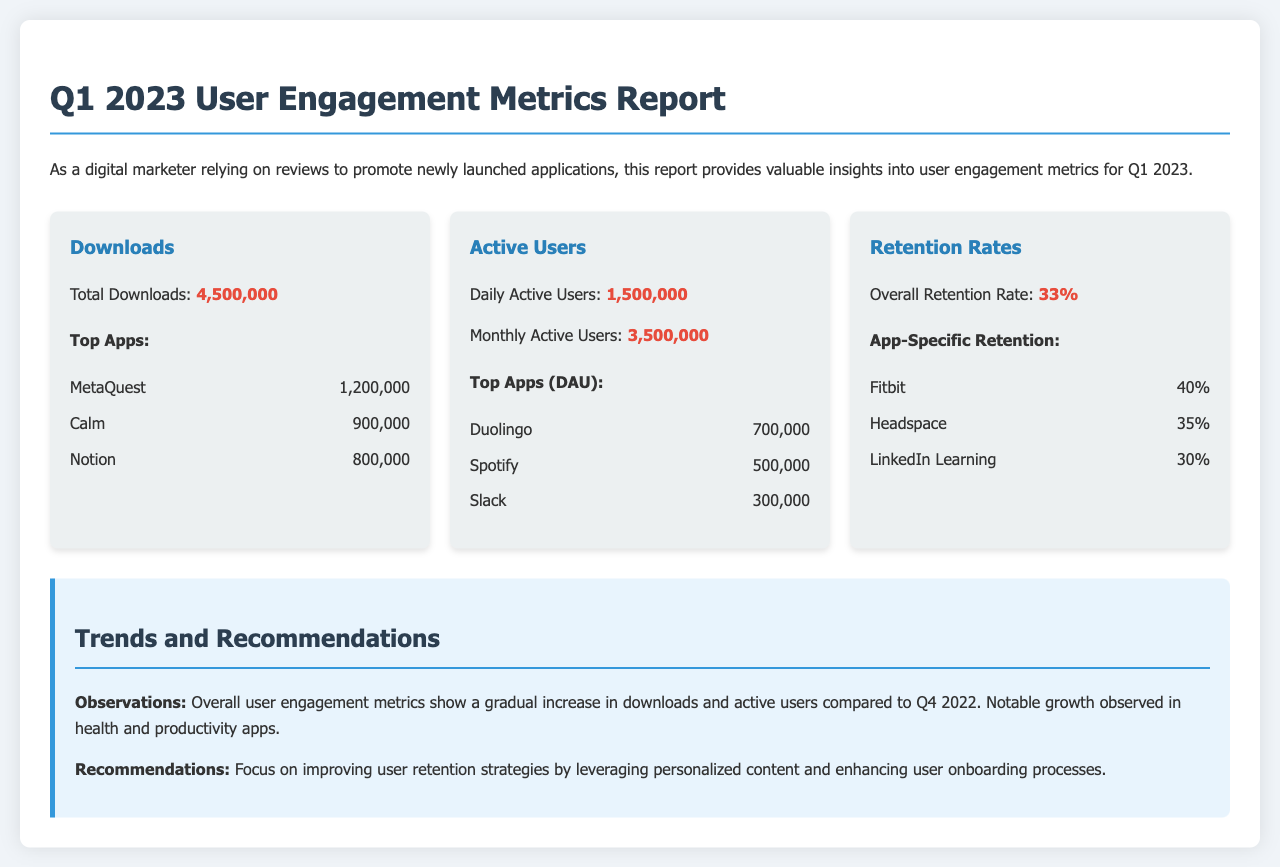What is the total number of downloads? The total number of downloads listed in the document is 4,500,000.
Answer: 4,500,000 What is the daily active users' count? The daily active users mentioned in the document is 1,500,000.
Answer: 1,500,000 What is the overall retention rate? The overall retention rate specified in the document is 33%.
Answer: 33% Which app had the highest downloads? The app with the highest downloads is MetaQuest, with 1,200,000 downloads.
Answer: MetaQuest What percentage retention rate does Fitbit have? The retention rate for Fitbit, as stated in the document, is 40%.
Answer: 40% How many monthly active users are reported? The number of monthly active users reported in the document is 3,500,000.
Answer: 3,500,000 What is the trend observed in user engagement metrics compared to Q4 2022? The trend observed indicates a gradual increase in downloads and active users compared to Q4 2022.
Answer: Gradual increase Which app is noted for having 700,000 daily active users? The app noted for having 700,000 daily active users is Duolingo.
Answer: Duolingo What is a recommendation given in the report? One recommendation given in the report is to focus on improving user retention strategies.
Answer: Improve user retention strategies 